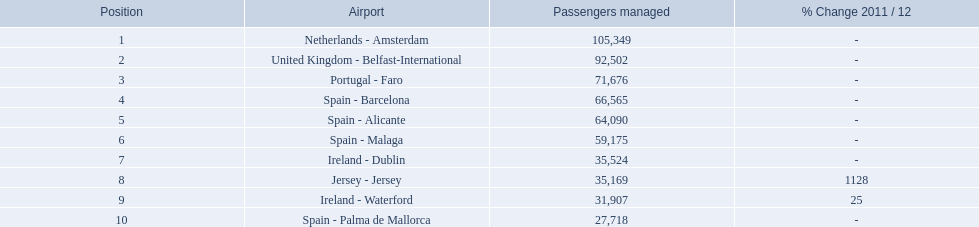Which airports had passengers going through london southend airport? Netherlands - Amsterdam, United Kingdom - Belfast-International, Portugal - Faro, Spain - Barcelona, Spain - Alicante, Spain - Malaga, Ireland - Dublin, Jersey - Jersey, Ireland - Waterford, Spain - Palma de Mallorca. Of those airports, which airport had the least amount of passengers going through london southend airport? Spain - Palma de Mallorca. What is the best rank? 1. What is the airport? Netherlands - Amsterdam. 